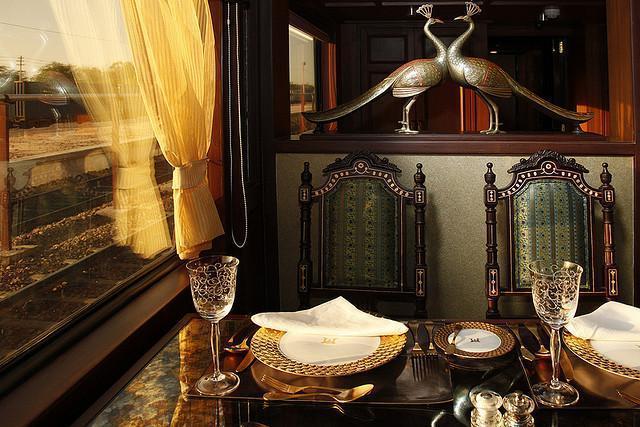How many glasses are in the picture?
Give a very brief answer. 2. How many chairs in the picture?
Give a very brief answer. 2. How many wine glasses are there?
Give a very brief answer. 2. How many dining tables are in the picture?
Give a very brief answer. 1. How many chairs are there?
Give a very brief answer. 2. 